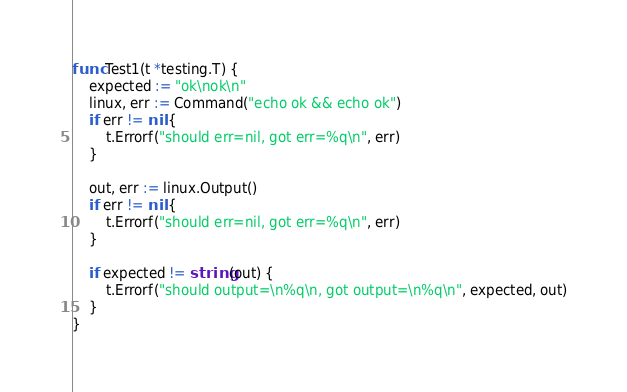<code> <loc_0><loc_0><loc_500><loc_500><_Go_>
func Test1(t *testing.T) {
	expected := "ok\nok\n"
	linux, err := Command("echo ok && echo ok")
	if err != nil {
		t.Errorf("should err=nil, got err=%q\n", err)
	}

	out, err := linux.Output()
	if err != nil {
		t.Errorf("should err=nil, got err=%q\n", err)
	}

	if expected != string(out) {
		t.Errorf("should output=\n%q\n, got output=\n%q\n", expected, out)
	}
}
</code> 